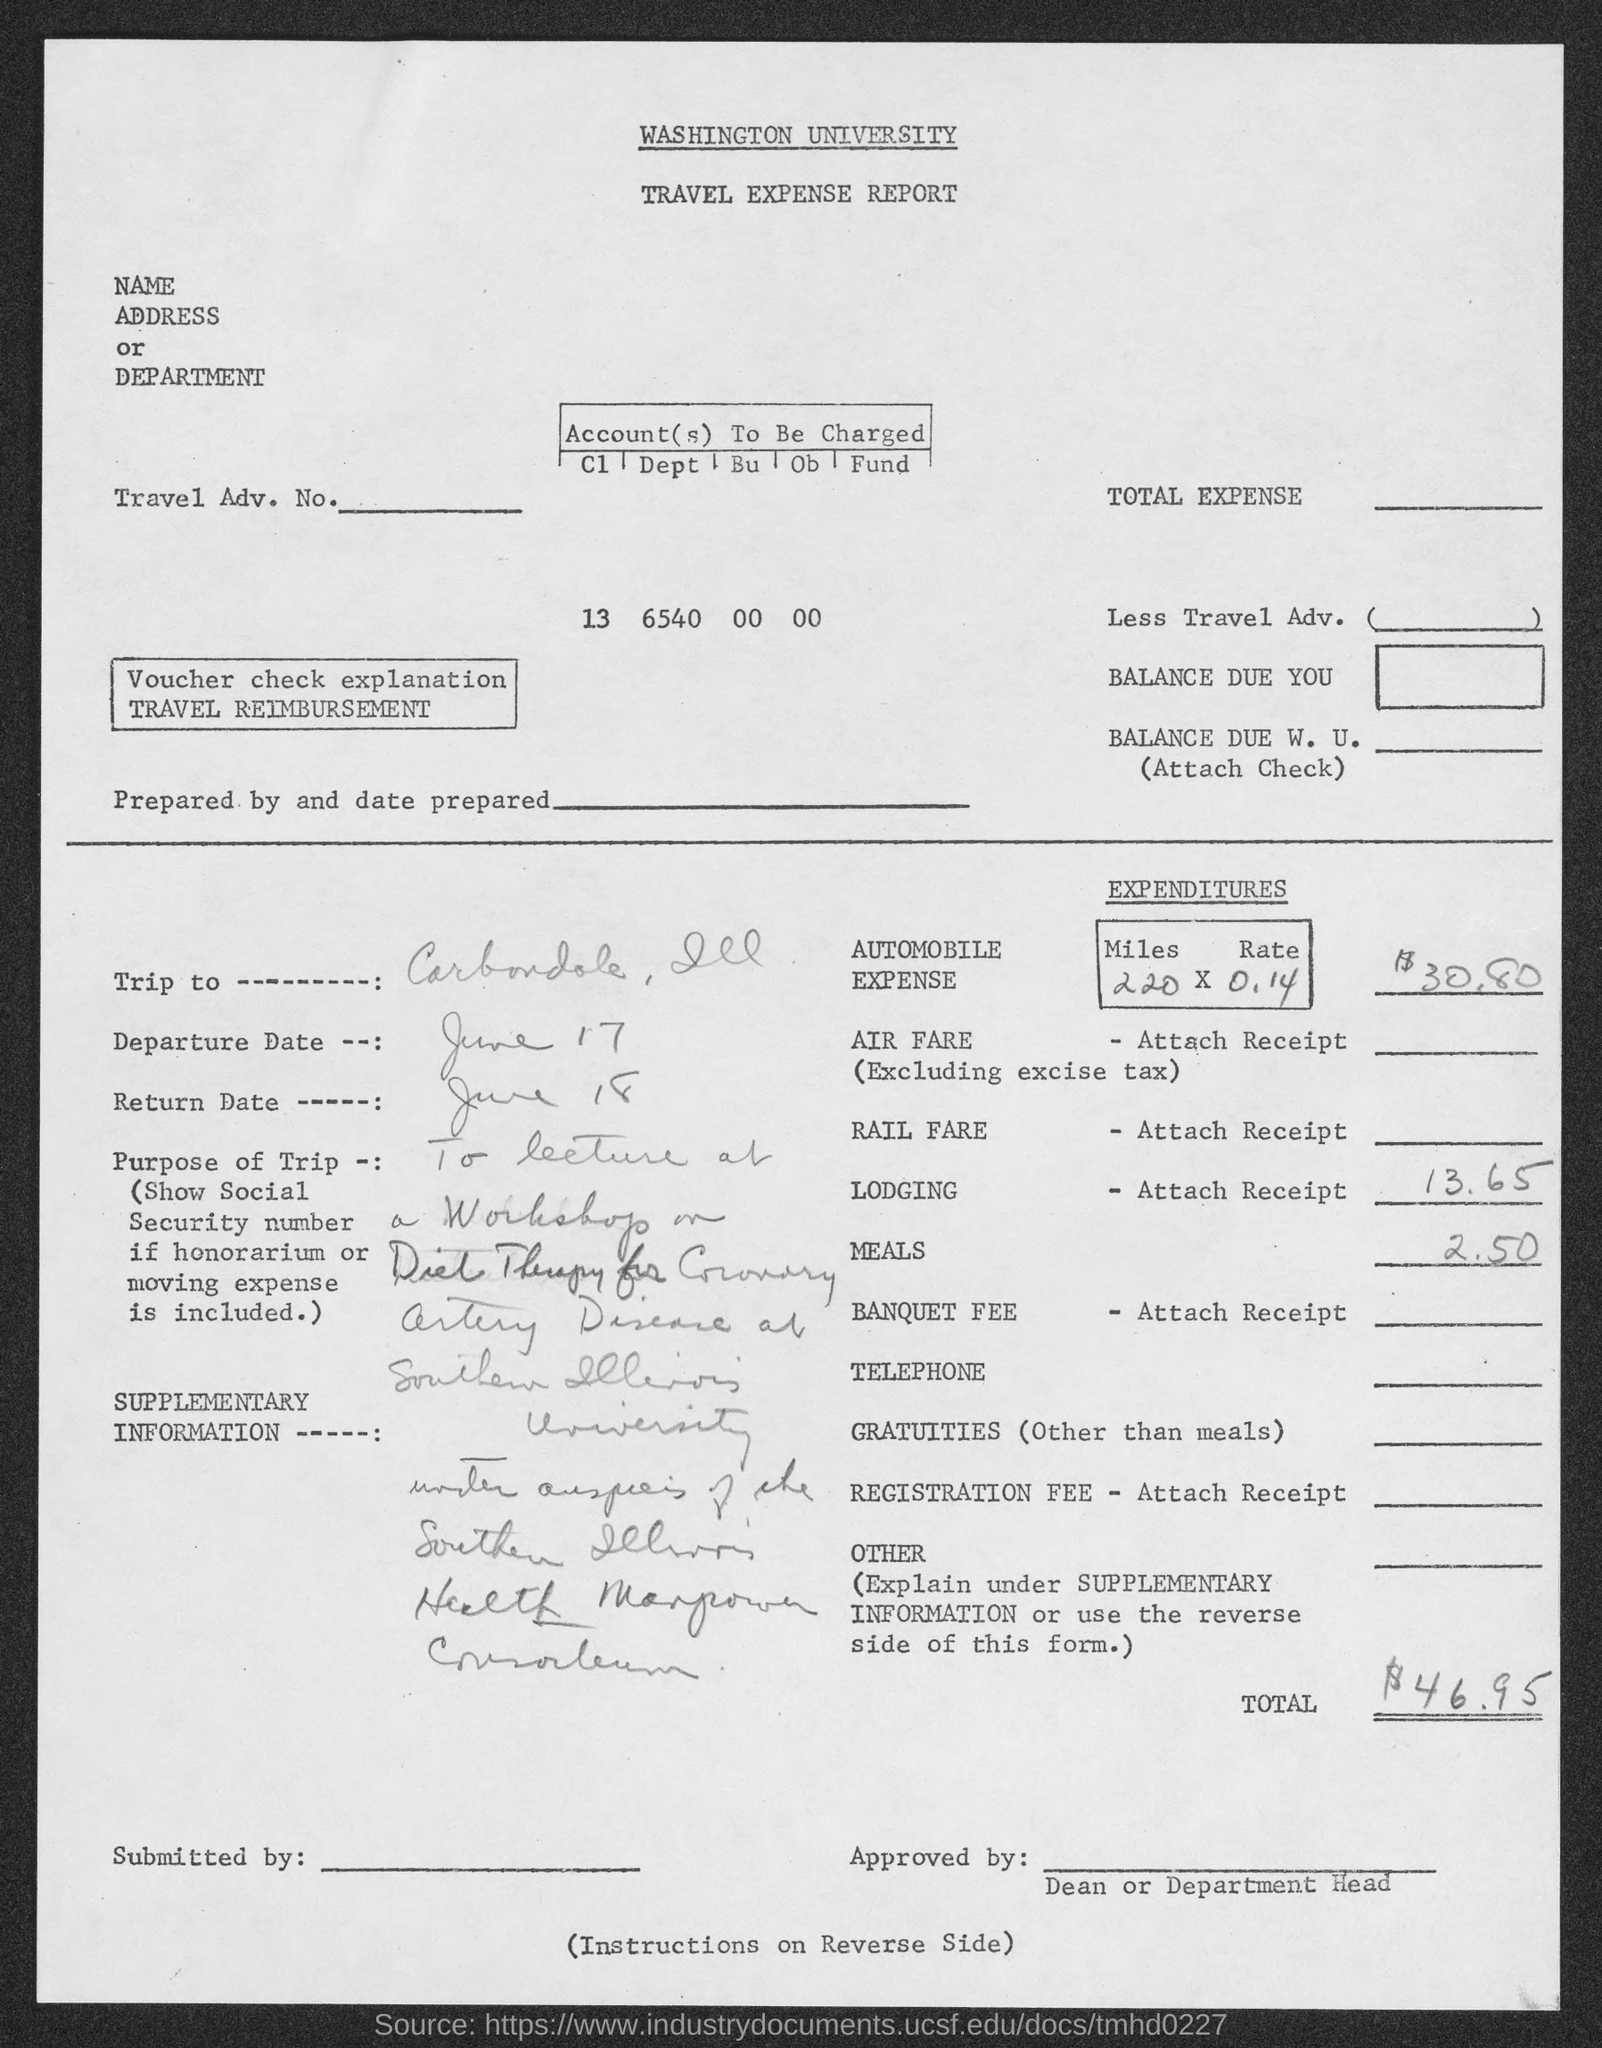List a handful of essential elements in this visual. The automobile expense in the travel expense report is $30.80. The given travel expense report belongs to Washington University. The departure date in the travel expense report is June 17. The return date mentioned in the travel expense report is June 18. The total expenditure as stated in the travel expense report is $46.95. 